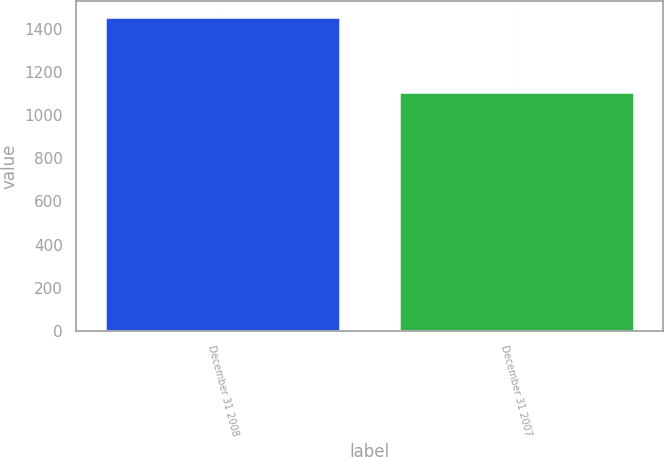Convert chart to OTSL. <chart><loc_0><loc_0><loc_500><loc_500><bar_chart><fcel>December 31 2008<fcel>December 31 2007<nl><fcel>1455<fcel>1108<nl></chart> 